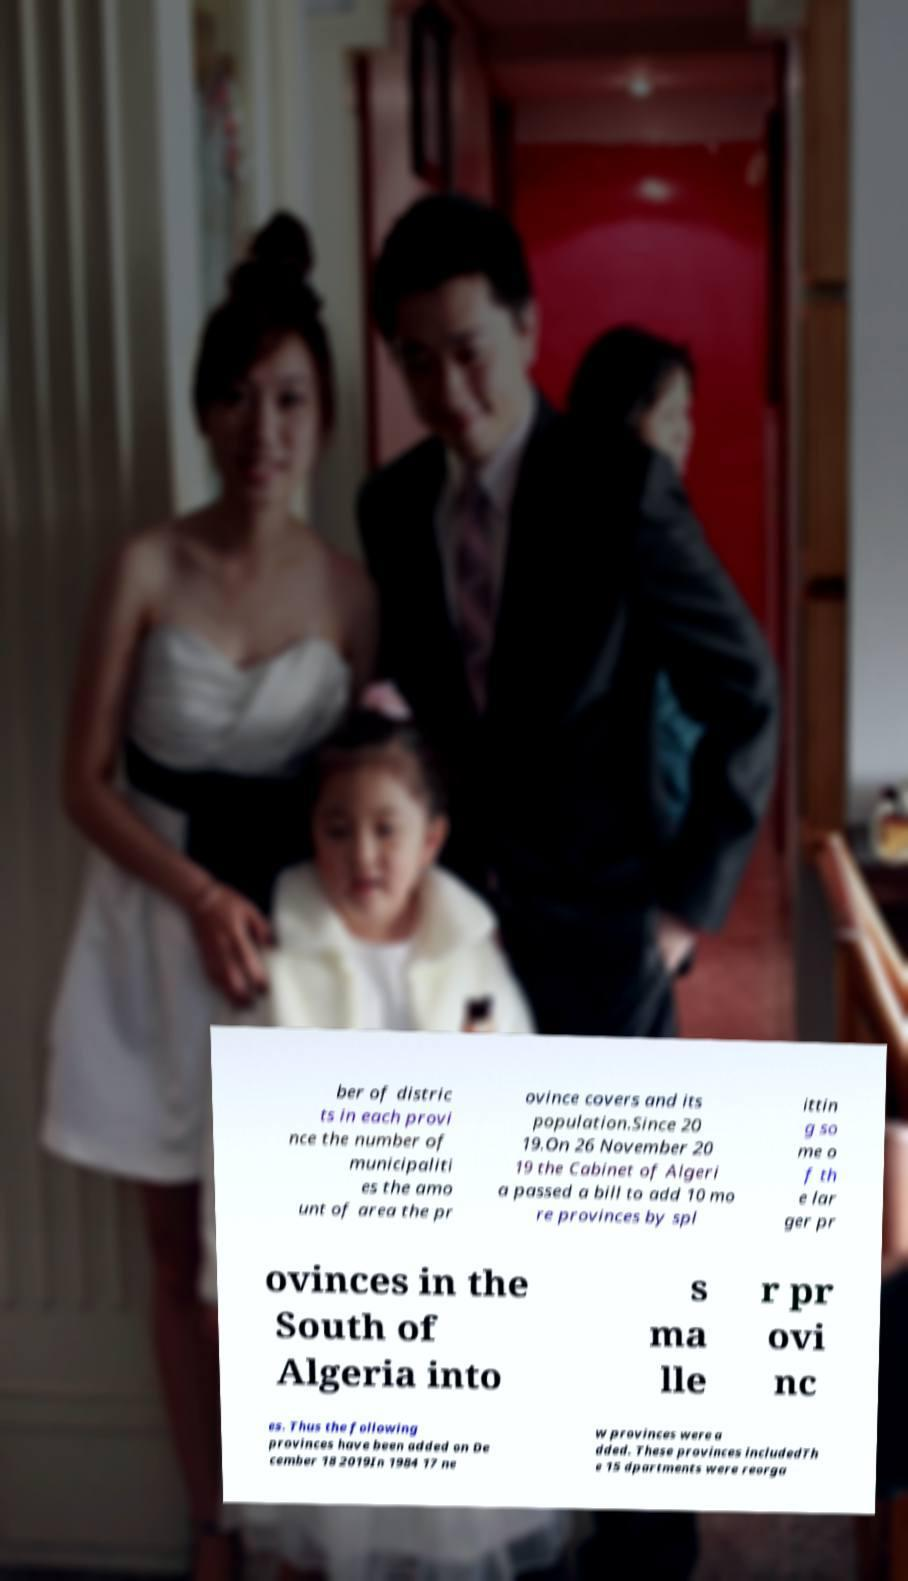What messages or text are displayed in this image? I need them in a readable, typed format. ber of distric ts in each provi nce the number of municipaliti es the amo unt of area the pr ovince covers and its population.Since 20 19.On 26 November 20 19 the Cabinet of Algeri a passed a bill to add 10 mo re provinces by spl ittin g so me o f th e lar ger pr ovinces in the South of Algeria into s ma lle r pr ovi nc es. Thus the following provinces have been added on De cember 18 2019In 1984 17 ne w provinces were a dded. These provinces includedTh e 15 dpartments were reorga 